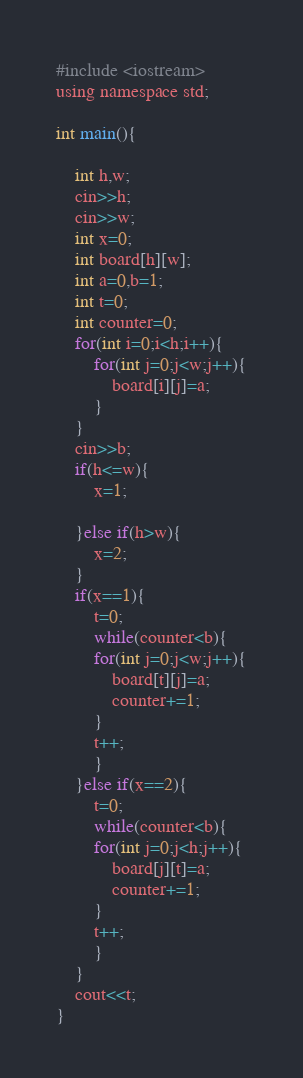<code> <loc_0><loc_0><loc_500><loc_500><_C_>#include <iostream>
using namespace std;

int main(){
    
    int h,w;
    cin>>h;
    cin>>w;
    int x=0;
    int board[h][w];
    int a=0,b=1;
    int t=0;
    int counter=0;
    for(int i=0;i<h;i++){
        for(int j=0;j<w;j++){
            board[i][j]=a;
        }
    }
    cin>>b;
    if(h<=w){
        x=1;
        
    }else if(h>w){
        x=2;
    }
    if(x==1){
        t=0;
        while(counter<b){
        for(int j=0;j<w;j++){
            board[t][j]=a;
            counter+=1;
        }
        t++;
        }
    }else if(x==2){
        t=0;
        while(counter<b){
        for(int j=0;j<h;j++){
            board[j][t]=a;
            counter+=1;
        }
        t++;
        }
    }
    cout<<t;
}
</code> 